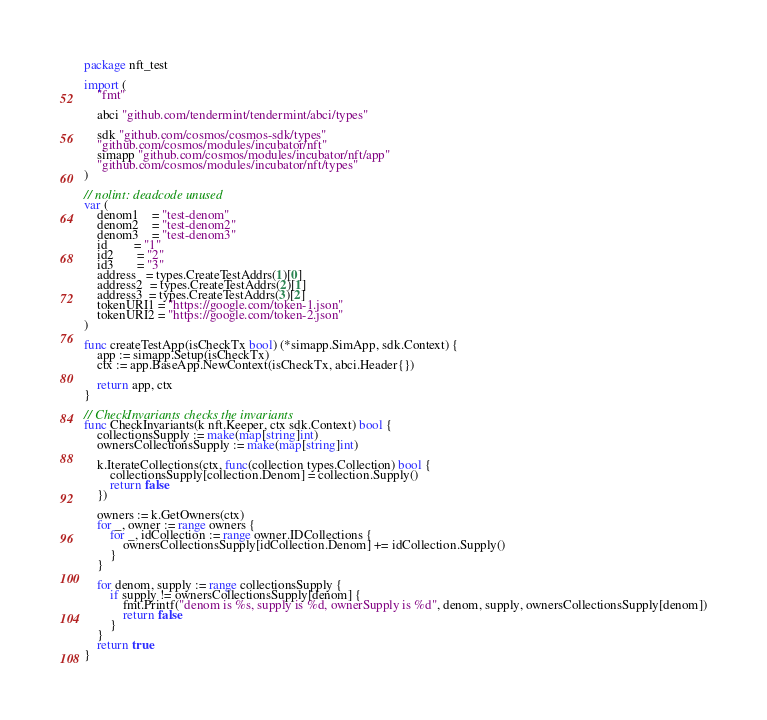<code> <loc_0><loc_0><loc_500><loc_500><_Go_>package nft_test

import (
	"fmt"

	abci "github.com/tendermint/tendermint/abci/types"

	sdk "github.com/cosmos/cosmos-sdk/types"
	"github.com/cosmos/modules/incubator/nft"
	simapp "github.com/cosmos/modules/incubator/nft/app"
	"github.com/cosmos/modules/incubator/nft/types"
)

// nolint: deadcode unused
var (
	denom1    = "test-denom"
	denom2    = "test-denom2"
	denom3    = "test-denom3"
	id        = "1"
	id2       = "2"
	id3       = "3"
	address   = types.CreateTestAddrs(1)[0]
	address2  = types.CreateTestAddrs(2)[1]
	address3  = types.CreateTestAddrs(3)[2]
	tokenURI1 = "https://google.com/token-1.json"
	tokenURI2 = "https://google.com/token-2.json"
)

func createTestApp(isCheckTx bool) (*simapp.SimApp, sdk.Context) {
	app := simapp.Setup(isCheckTx)
	ctx := app.BaseApp.NewContext(isCheckTx, abci.Header{})

	return app, ctx
}

// CheckInvariants checks the invariants
func CheckInvariants(k nft.Keeper, ctx sdk.Context) bool {
	collectionsSupply := make(map[string]int)
	ownersCollectionsSupply := make(map[string]int)

	k.IterateCollections(ctx, func(collection types.Collection) bool {
		collectionsSupply[collection.Denom] = collection.Supply()
		return false
	})

	owners := k.GetOwners(ctx)
	for _, owner := range owners {
		for _, idCollection := range owner.IDCollections {
			ownersCollectionsSupply[idCollection.Denom] += idCollection.Supply()
		}
	}

	for denom, supply := range collectionsSupply {
		if supply != ownersCollectionsSupply[denom] {
			fmt.Printf("denom is %s, supply is %d, ownerSupply is %d", denom, supply, ownersCollectionsSupply[denom])
			return false
		}
	}
	return true
}
</code> 